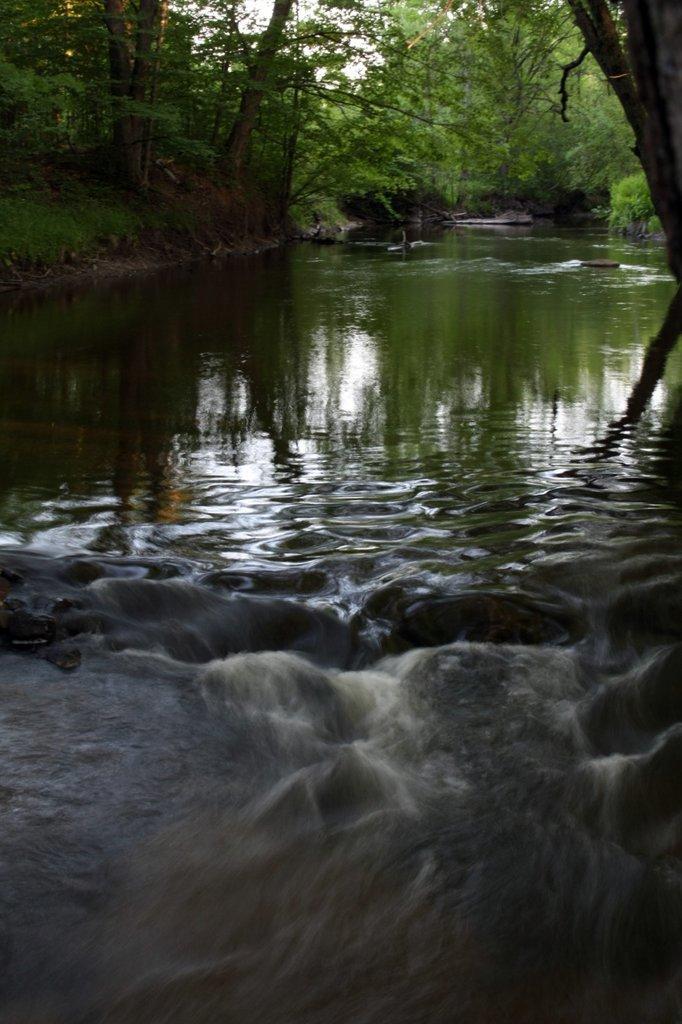Please provide a concise description of this image. There is water and trees are present at the back. 